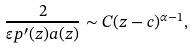<formula> <loc_0><loc_0><loc_500><loc_500>\frac { 2 } { \varepsilon p ^ { \prime } ( z ) a ( z ) } \sim C ( z - c ) ^ { \alpha - 1 } ,</formula> 